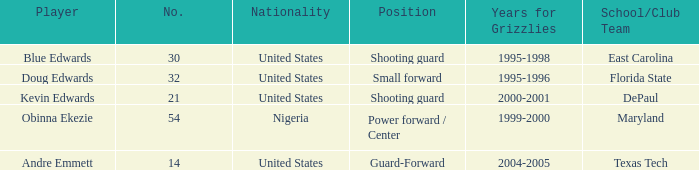What's the highest player number from the list from 2000-2001 21.0. 